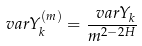<formula> <loc_0><loc_0><loc_500><loc_500>\ v a r { Y _ { k } ^ { ( m ) } } = \frac { \ v a r { Y _ { k } } } { m ^ { 2 - 2 H } }</formula> 